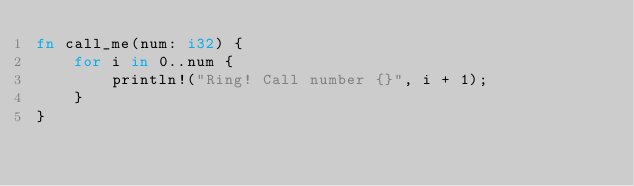Convert code to text. <code><loc_0><loc_0><loc_500><loc_500><_Rust_>fn call_me(num: i32) {
    for i in 0..num {
        println!("Ring! Call number {}", i + 1);
    }
}
</code> 